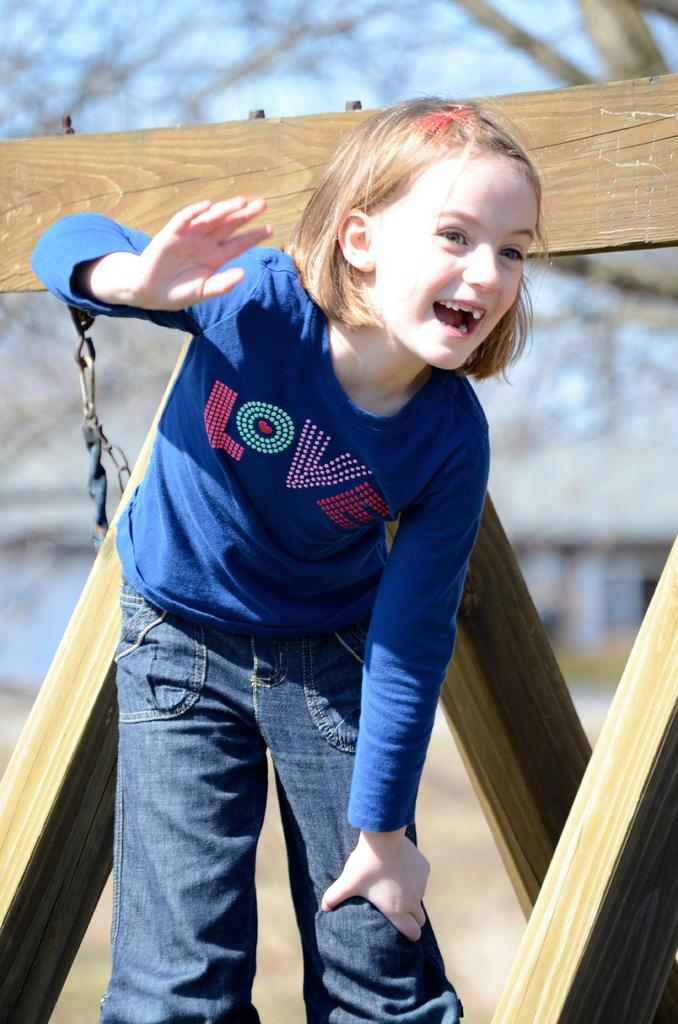Who is the main subject in the image? There is a girl in the image. What is the girl wearing? The girl is wearing a blue t-shirt and jeans. What is the girl's facial expression in the image? The girl is smiling. What type of material can be seen in the image? Wood and a chain are visible in the image. What type of friction can be observed between the girl and the vest in the image? There is no vest present in the image, and therefore no friction can be observed between the girl and a vest. 